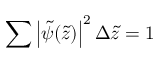<formula> <loc_0><loc_0><loc_500><loc_500>\sum \left | \tilde { \psi } ( \tilde { z } ) \right | ^ { 2 } \Delta \tilde { z } = 1</formula> 